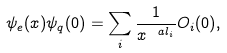<formula> <loc_0><loc_0><loc_500><loc_500>\psi _ { e } ( x ) \psi _ { q } ( 0 ) = \sum _ { i } \frac { 1 } { x ^ { \ a l _ { i } } } O _ { i } ( 0 ) ,</formula> 